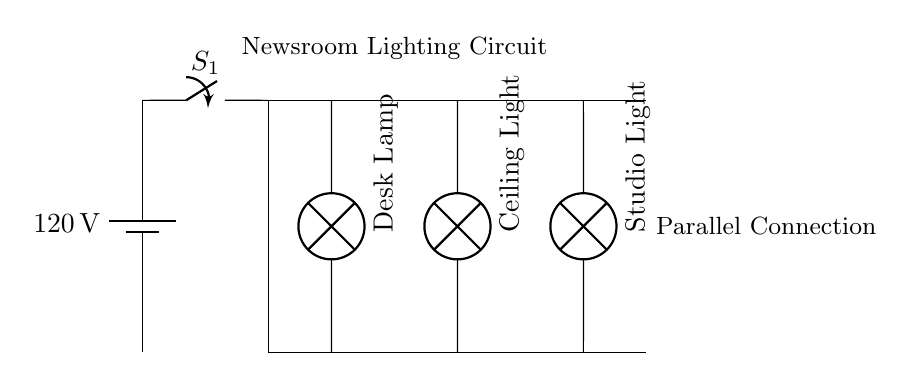What is the voltage source in this circuit? The circuit shows a battery labeled with 120 volts, indicating this is the potential difference supplied to the circuit.
Answer: 120 volts What type of circuit is represented here? This circuit showcases a parallel connection as depicted by the multiple branches for lighting fixtures leading from a single distribution line.
Answer: Parallel How many lighting fixtures are connected? The diagram illustrates three distinct lighting fixtures, each connected to the main distribution line in parallel.
Answer: Three What is the function of switch S1? Switch S1 serves to either open or close the circuit, allowing or stopping the flow of electrical current to the connected lighting fixtures.
Answer: Control How would the removal of one fixture affect the others? In a parallel circuit, the removal of one fixture does not impact the operation of the others, as they are connected independently to the voltage supply.
Answer: No effect Which lighting fixture is located furthest from the power source? The Studio Light fixture is positioned at the far right, indicating it is the furthest from the main power source.
Answer: Studio Light What is the purpose of the distribution lines in this circuit? The distribution lines are essential for routing the electrical current from the voltage source to each individual lighting fixture connected in parallel.
Answer: Distribution 